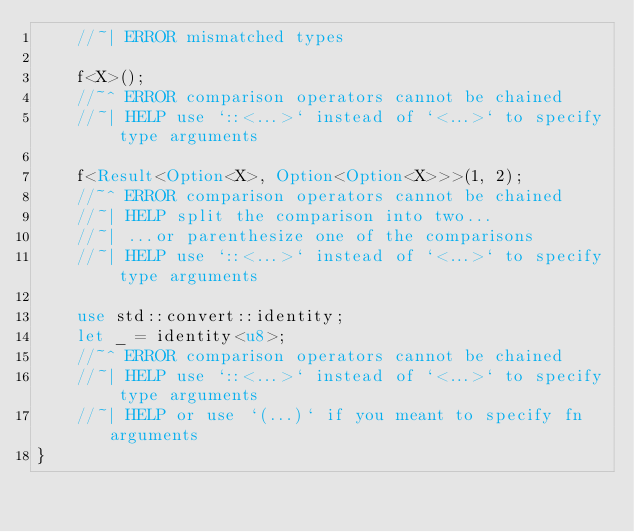Convert code to text. <code><loc_0><loc_0><loc_500><loc_500><_Rust_>    //~| ERROR mismatched types

    f<X>();
    //~^ ERROR comparison operators cannot be chained
    //~| HELP use `::<...>` instead of `<...>` to specify type arguments

    f<Result<Option<X>, Option<Option<X>>>(1, 2);
    //~^ ERROR comparison operators cannot be chained
    //~| HELP split the comparison into two...
    //~| ...or parenthesize one of the comparisons
    //~| HELP use `::<...>` instead of `<...>` to specify type arguments

    use std::convert::identity;
    let _ = identity<u8>;
    //~^ ERROR comparison operators cannot be chained
    //~| HELP use `::<...>` instead of `<...>` to specify type arguments
    //~| HELP or use `(...)` if you meant to specify fn arguments
}
</code> 